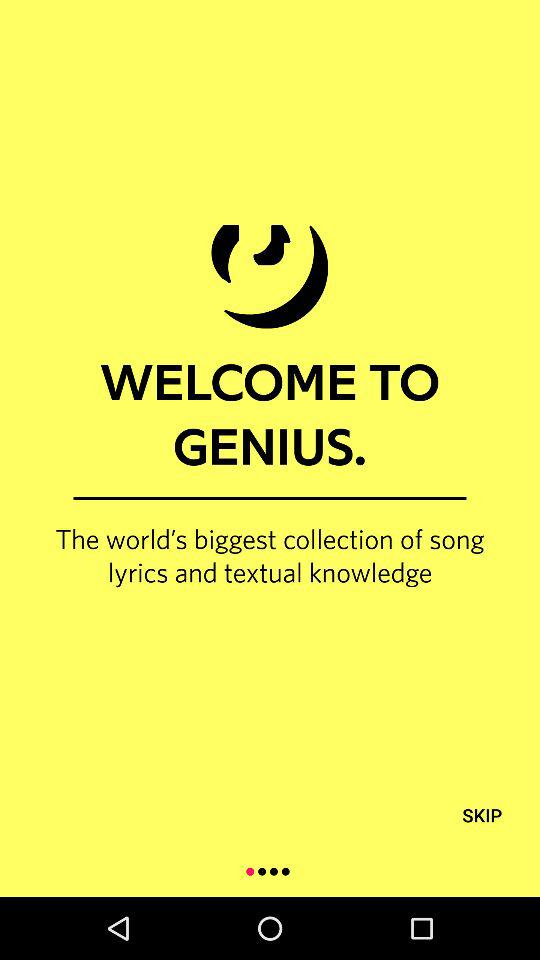What is the name of the application? The name of the application is "GENIUS.". 